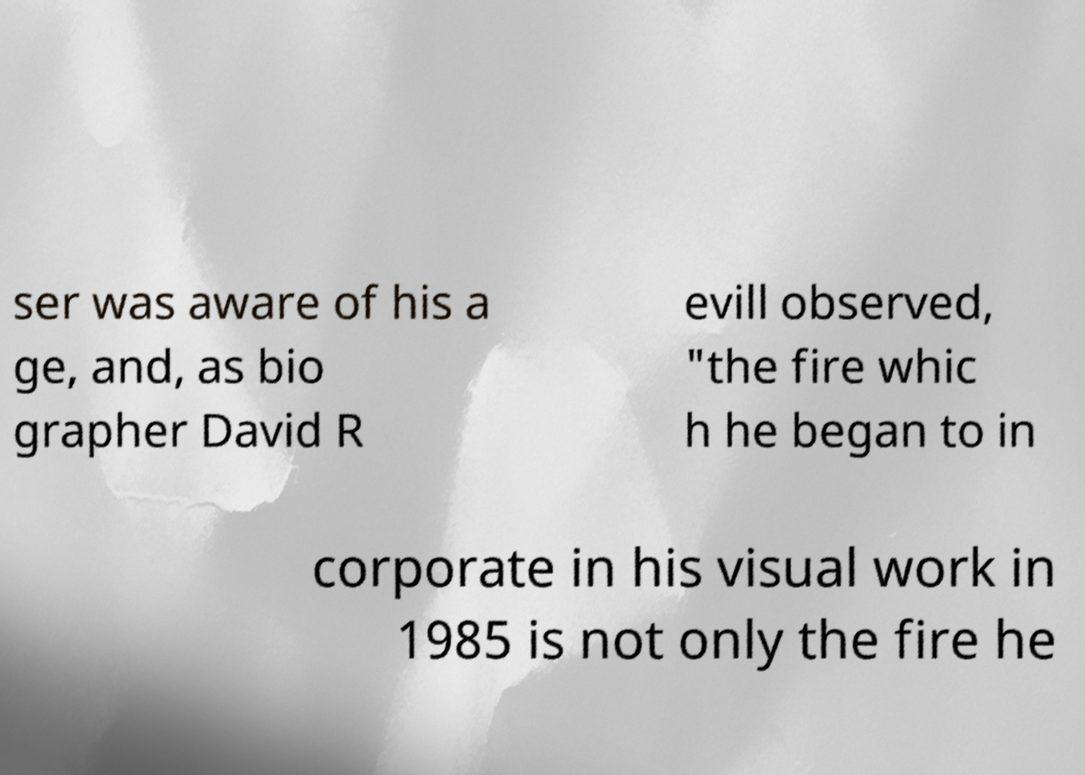For documentation purposes, I need the text within this image transcribed. Could you provide that? ser was aware of his a ge, and, as bio grapher David R evill observed, "the fire whic h he began to in corporate in his visual work in 1985 is not only the fire he 